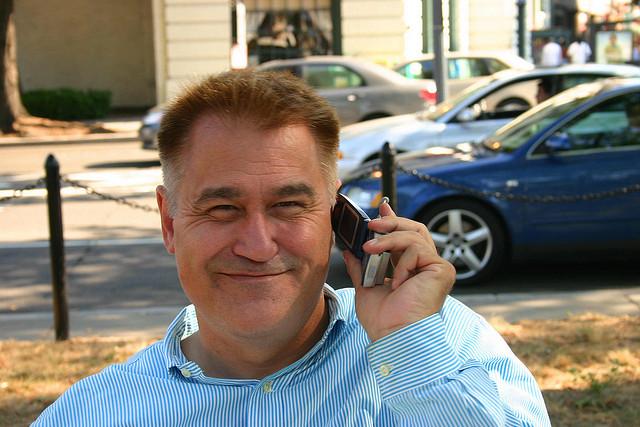Do you see any red cars?
Be succinct. No. Can you see a blue car?
Give a very brief answer. Yes. Is this a flip phone?
Quick response, please. Yes. Is this man talking or listening?
Short answer required. Listening. 